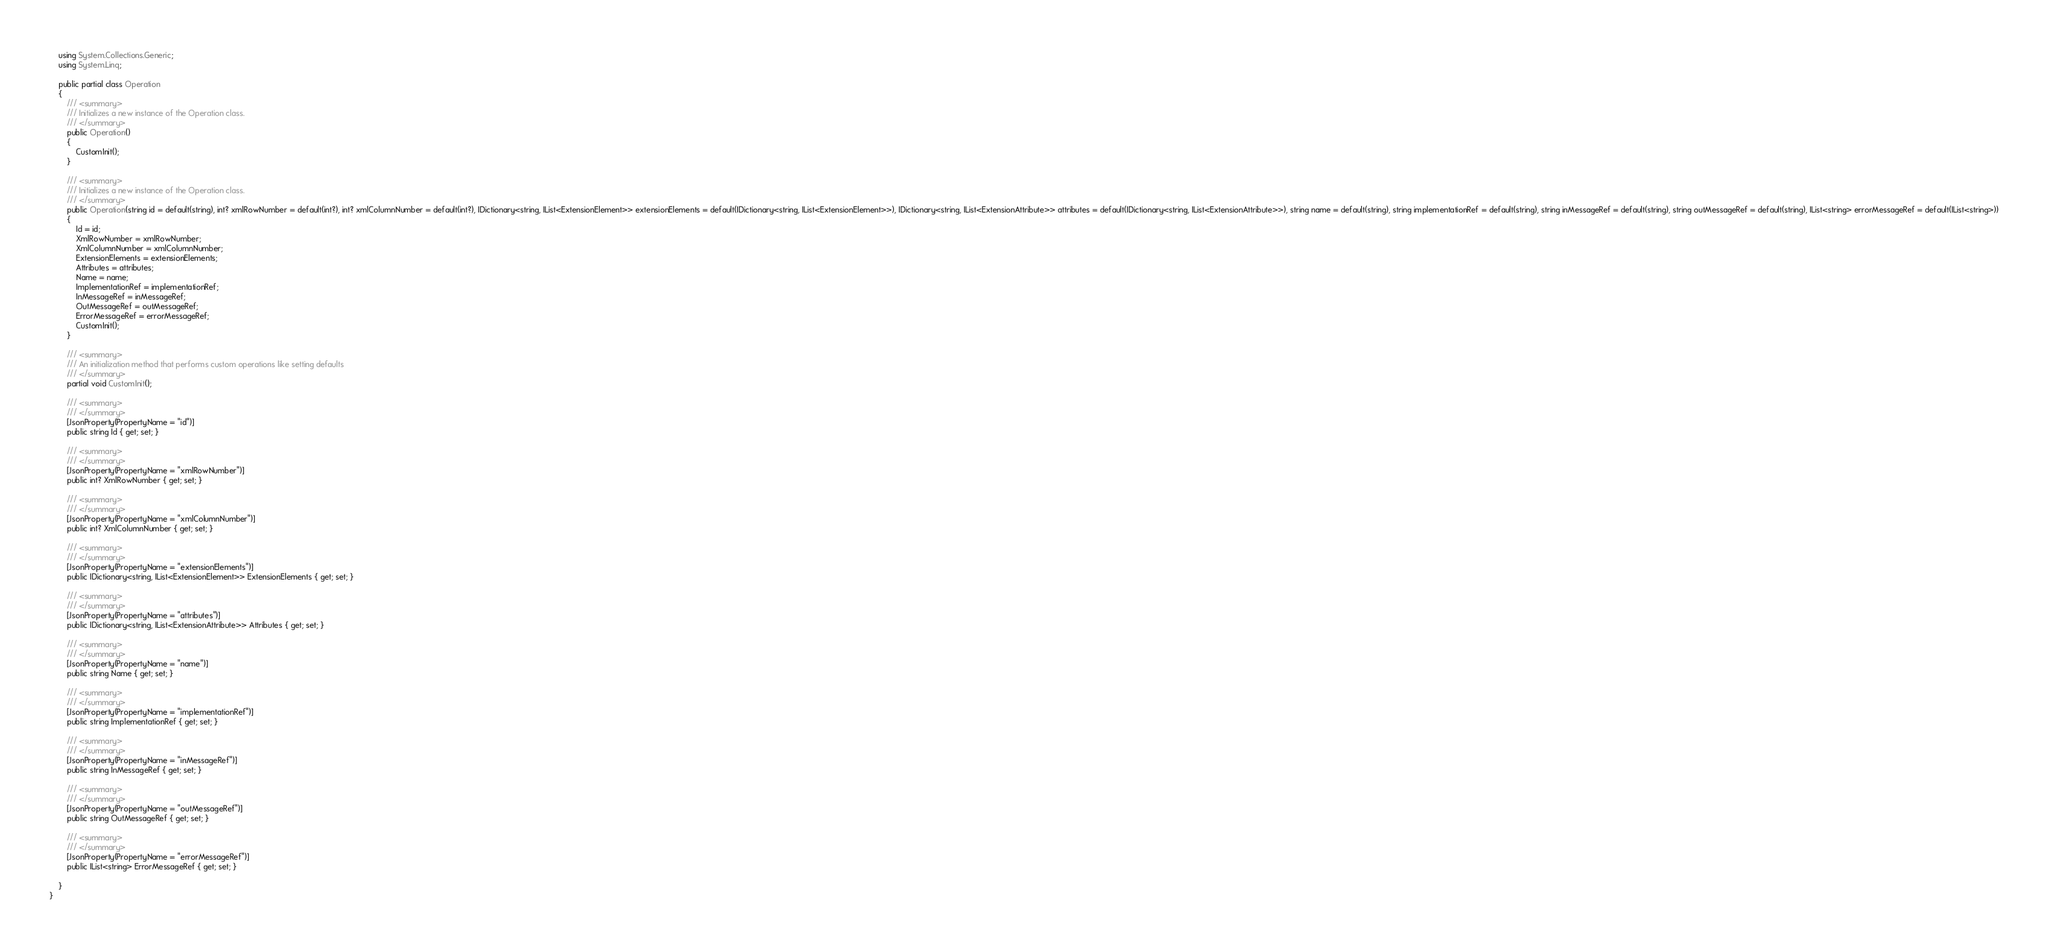<code> <loc_0><loc_0><loc_500><loc_500><_C#_>    using System.Collections.Generic;
    using System.Linq;

    public partial class Operation
    {
        /// <summary>
        /// Initializes a new instance of the Operation class.
        /// </summary>
        public Operation()
        {
            CustomInit();
        }

        /// <summary>
        /// Initializes a new instance of the Operation class.
        /// </summary>
        public Operation(string id = default(string), int? xmlRowNumber = default(int?), int? xmlColumnNumber = default(int?), IDictionary<string, IList<ExtensionElement>> extensionElements = default(IDictionary<string, IList<ExtensionElement>>), IDictionary<string, IList<ExtensionAttribute>> attributes = default(IDictionary<string, IList<ExtensionAttribute>>), string name = default(string), string implementationRef = default(string), string inMessageRef = default(string), string outMessageRef = default(string), IList<string> errorMessageRef = default(IList<string>))
        {
            Id = id;
            XmlRowNumber = xmlRowNumber;
            XmlColumnNumber = xmlColumnNumber;
            ExtensionElements = extensionElements;
            Attributes = attributes;
            Name = name;
            ImplementationRef = implementationRef;
            InMessageRef = inMessageRef;
            OutMessageRef = outMessageRef;
            ErrorMessageRef = errorMessageRef;
            CustomInit();
        }

        /// <summary>
        /// An initialization method that performs custom operations like setting defaults
        /// </summary>
        partial void CustomInit();

        /// <summary>
        /// </summary>
        [JsonProperty(PropertyName = "id")]
        public string Id { get; set; }

        /// <summary>
        /// </summary>
        [JsonProperty(PropertyName = "xmlRowNumber")]
        public int? XmlRowNumber { get; set; }

        /// <summary>
        /// </summary>
        [JsonProperty(PropertyName = "xmlColumnNumber")]
        public int? XmlColumnNumber { get; set; }

        /// <summary>
        /// </summary>
        [JsonProperty(PropertyName = "extensionElements")]
        public IDictionary<string, IList<ExtensionElement>> ExtensionElements { get; set; }

        /// <summary>
        /// </summary>
        [JsonProperty(PropertyName = "attributes")]
        public IDictionary<string, IList<ExtensionAttribute>> Attributes { get; set; }

        /// <summary>
        /// </summary>
        [JsonProperty(PropertyName = "name")]
        public string Name { get; set; }

        /// <summary>
        /// </summary>
        [JsonProperty(PropertyName = "implementationRef")]
        public string ImplementationRef { get; set; }

        /// <summary>
        /// </summary>
        [JsonProperty(PropertyName = "inMessageRef")]
        public string InMessageRef { get; set; }

        /// <summary>
        /// </summary>
        [JsonProperty(PropertyName = "outMessageRef")]
        public string OutMessageRef { get; set; }

        /// <summary>
        /// </summary>
        [JsonProperty(PropertyName = "errorMessageRef")]
        public IList<string> ErrorMessageRef { get; set; }

    }
}
</code> 